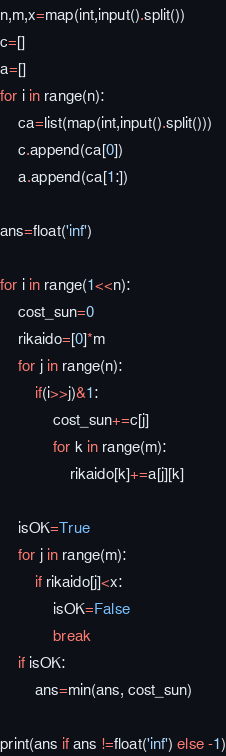Convert code to text. <code><loc_0><loc_0><loc_500><loc_500><_Python_>n,m,x=map(int,input().split())
c=[]
a=[]
for i in range(n):
    ca=list(map(int,input().split()))
    c.append(ca[0])
    a.append(ca[1:])

ans=float('inf')

for i in range(1<<n):
    cost_sun=0
    rikaido=[0]*m
    for j in range(n):
        if(i>>j)&1:
            cost_sun+=c[j]
            for k in range(m):
                rikaido[k]+=a[j][k]
    
    isOK=True
    for j in range(m):
        if rikaido[j]<x:
            isOK=False
            break
    if isOK:
        ans=min(ans, cost_sun)

print(ans if ans !=float('inf') else -1)</code> 